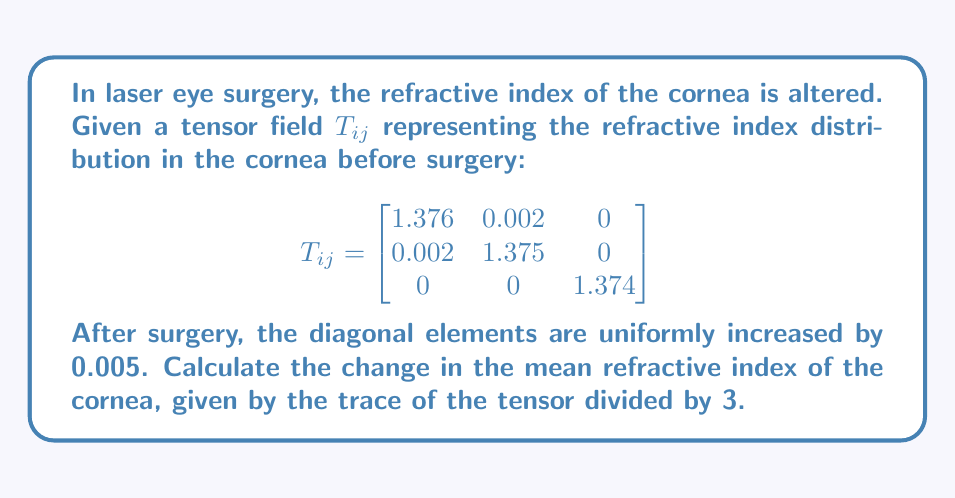Show me your answer to this math problem. To solve this problem, we'll follow these steps:

1) First, let's recall that the trace of a tensor is the sum of its diagonal elements.

2) Before surgery, the trace of $T_{ij}$ is:
   $$\text{Tr}(T_{ij}) = 1.376 + 1.375 + 1.374 = 4.125$$

3) The mean refractive index before surgery is:
   $$n_{\text{before}} = \frac{\text{Tr}(T_{ij})}{3} = \frac{4.125}{3} = 1.375$$

4) After surgery, each diagonal element increases by 0.005. The new tensor $T'_{ij}$ is:

   $$T'_{ij} = \begin{bmatrix}
   1.381 & 0.002 & 0 \\
   0.002 & 1.380 & 0 \\
   0 & 0 & 1.379
   \end{bmatrix}$$

5) The trace of $T'_{ij}$ is:
   $$\text{Tr}(T'_{ij}) = 1.381 + 1.380 + 1.379 = 4.140$$

6) The mean refractive index after surgery is:
   $$n_{\text{after}} = \frac{\text{Tr}(T'_{ij})}{3} = \frac{4.140}{3} = 1.380$$

7) The change in mean refractive index is:
   $$\Delta n = n_{\text{after}} - n_{\text{before}} = 1.380 - 1.375 = 0.005$$
Answer: $\Delta n = 0.005$ 